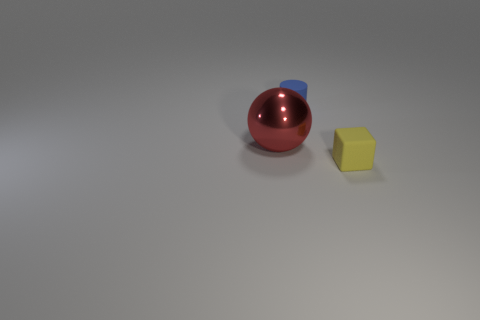What number of things are either small purple rubber cubes or large objects?
Make the answer very short. 1. Is the size of the blue cylinder the same as the red shiny sphere left of the yellow rubber object?
Give a very brief answer. No. What number of other objects are the same material as the tiny yellow object?
Keep it short and to the point. 1. What number of things are tiny rubber things behind the large thing or small matte objects that are behind the red thing?
Your answer should be very brief. 1. Are any rubber cylinders visible?
Offer a terse response. Yes. What size is the thing that is behind the yellow matte block and in front of the tiny blue thing?
Provide a short and direct response. Large. There is a tiny blue matte object; what shape is it?
Make the answer very short. Cylinder. Are there any small things that are on the left side of the yellow thing to the right of the red shiny sphere?
Ensure brevity in your answer.  Yes. Are there any yellow matte spheres of the same size as the metallic thing?
Provide a succinct answer. No. There is a thing left of the tiny blue cylinder; what is it made of?
Offer a very short reply. Metal. 